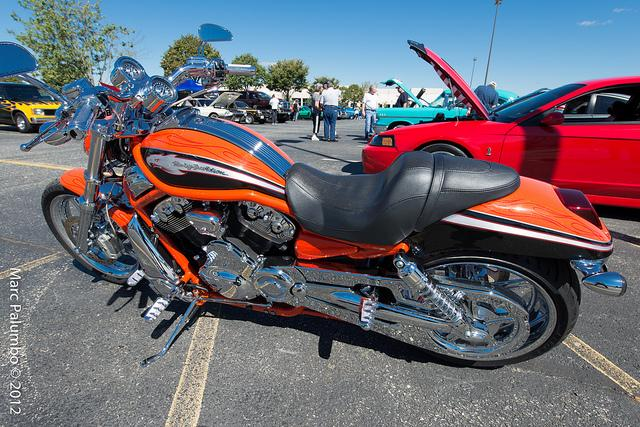What is the silver area of the bike made of?

Choices:
A) glass
B) chrome
C) pewter
D) plastic chrome 